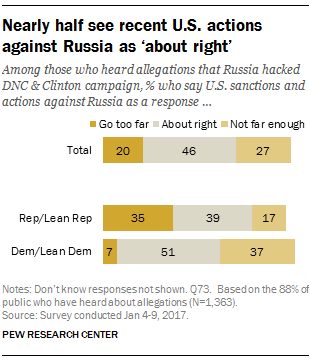Outline some significant characteristics in this image. There are three colors in the bar. Of all responses, 27% fall into the category of 'not far enough.' 